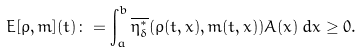Convert formula to latex. <formula><loc_0><loc_0><loc_500><loc_500>E [ \rho , m ] ( t ) \colon = \int _ { a } ^ { b } \overline { \eta _ { \delta } ^ { * } } ( \rho ( t , x ) , m ( t , x ) ) A ( x ) \, d x \geq 0 .</formula> 